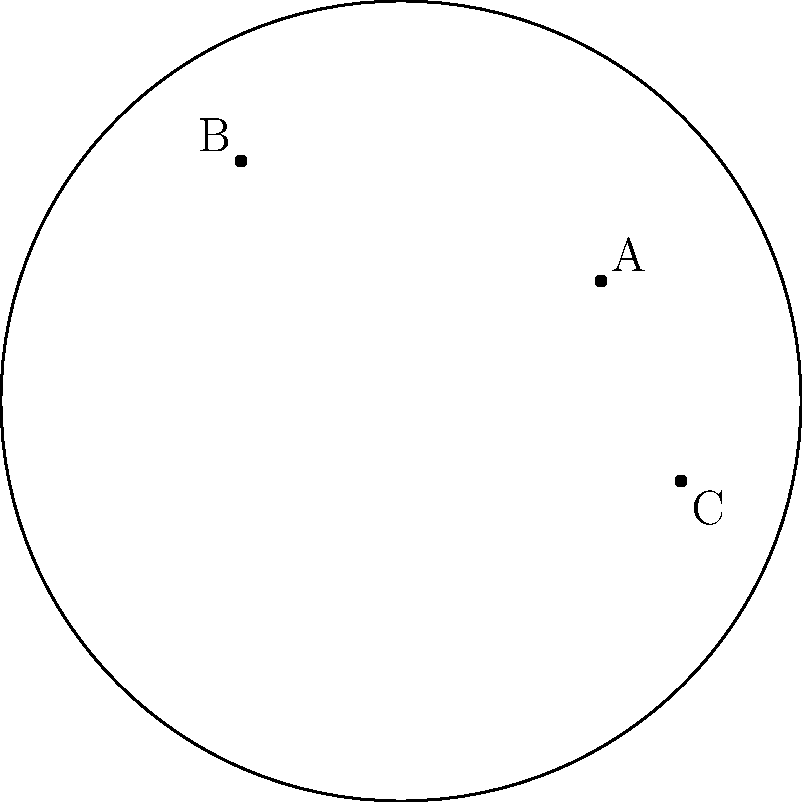In the Poincaré disk model of hyperbolic geometry shown above, three points A, B, and C are connected by geodesics (shortest paths) represented by circular arcs. If the hyperbolic distance between A and B is 2 units, and the distance between B and C is 1.5 units, what is the approximate hyperbolic distance between A and C? (Assume the radius of the disk is 1 unit.) To solve this problem, we need to follow these steps:

1) In the Poincaré disk model, the hyperbolic distance $d$ between two points $P_1(x_1, y_1)$ and $P_2(x_2, y_2)$ is given by:

   $$d = 2 \tanh^{-1}\left(\frac{|P_1 - P_2|}{|1 - P_1\overline{P_2}|}\right)$$

   where $|P_1 - P_2|$ is the Euclidean distance between the points and $\overline{P_2}$ is the complex conjugate of $P_2$.

2) We're given that $d_{AB} = 2$ and $d_{BC} = 1.5$. We need to find $d_{AC}$.

3) In hyperbolic geometry, the triangle inequality still holds, but it's usually a strict inequality. This means:

   $$d_{AC} < d_{AB} + d_{BC}$$

4) However, the hyperbolic distance is always greater than the Euclidean distance. So:

   $$d_{AC} > |A - C|$$

5) Given the positions of points A, B, and C in the disk, we can see that the arc AC is shorter than the sum of arcs AB and BC, but longer than the straight line AC.

6) Therefore, a reasonable estimate for $d_{AC}$ would be slightly less than $d_{AB} + d_{BC}$, but significantly more than the Euclidean distance $|A - C|$.

7) $d_{AB} + d_{BC} = 2 + 1.5 = 3.5$

8) A good estimate for $d_{AC}$ would be around 3 units.

This approach uses the geometric intuition that a long-time resident of Kachanivka might have developed about distances and paths in their local area, applied to the abstract setting of the Poincaré disk.
Answer: Approximately 3 units 